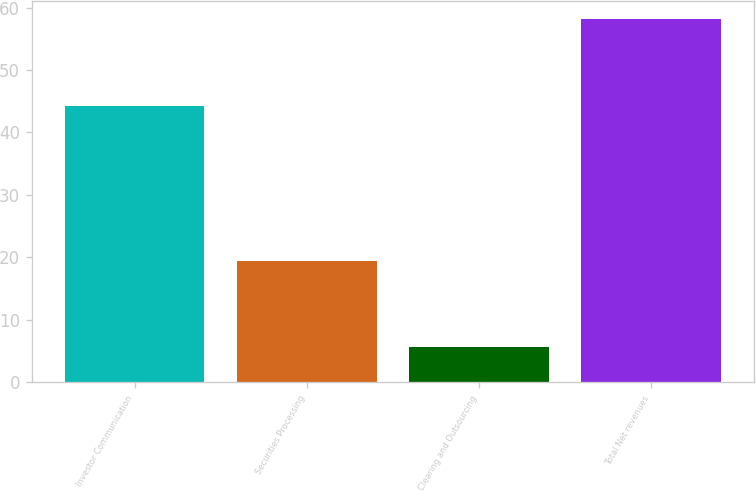<chart> <loc_0><loc_0><loc_500><loc_500><bar_chart><fcel>Investor Communication<fcel>Securities Processing<fcel>Clearing and Outsourcing<fcel>Total Net revenues<nl><fcel>44.2<fcel>19.4<fcel>5.6<fcel>58.2<nl></chart> 